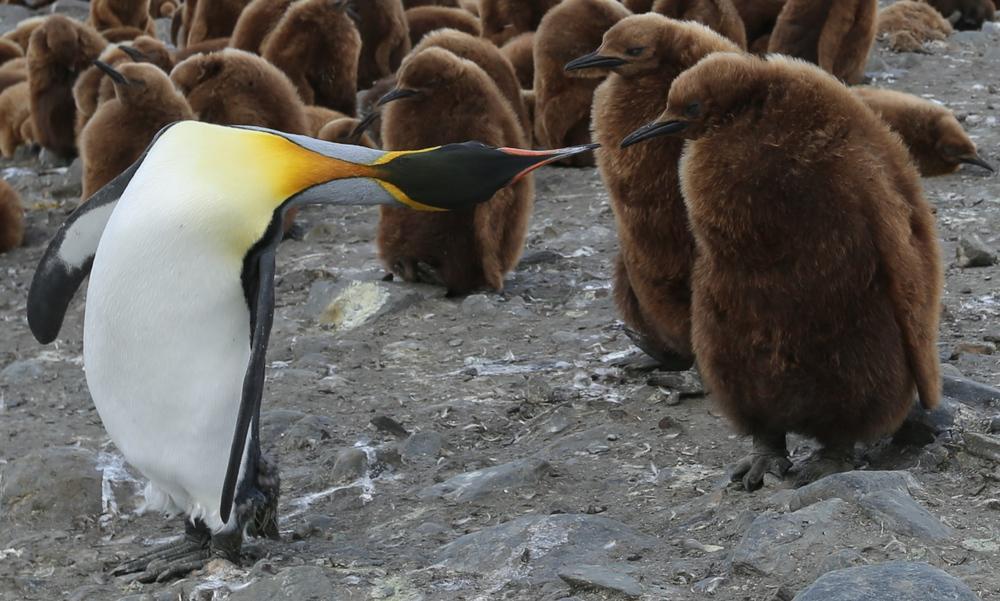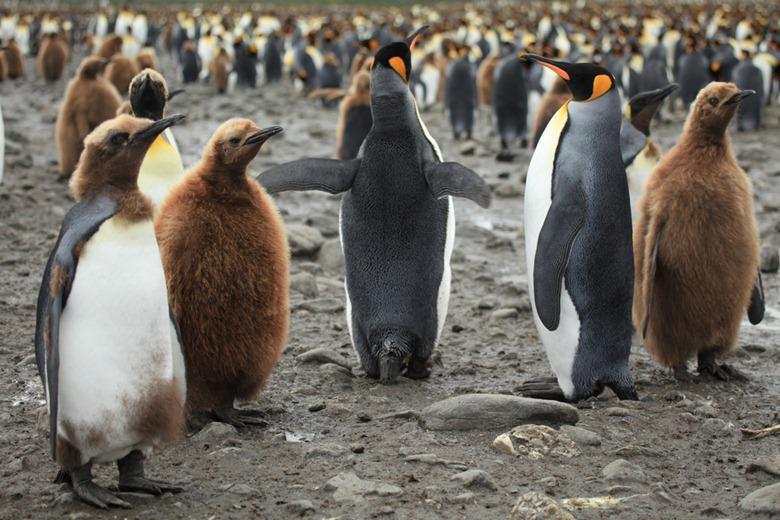The first image is the image on the left, the second image is the image on the right. Evaluate the accuracy of this statement regarding the images: "A hilly landform is behind some of the penguins.". Is it true? Answer yes or no. No. 